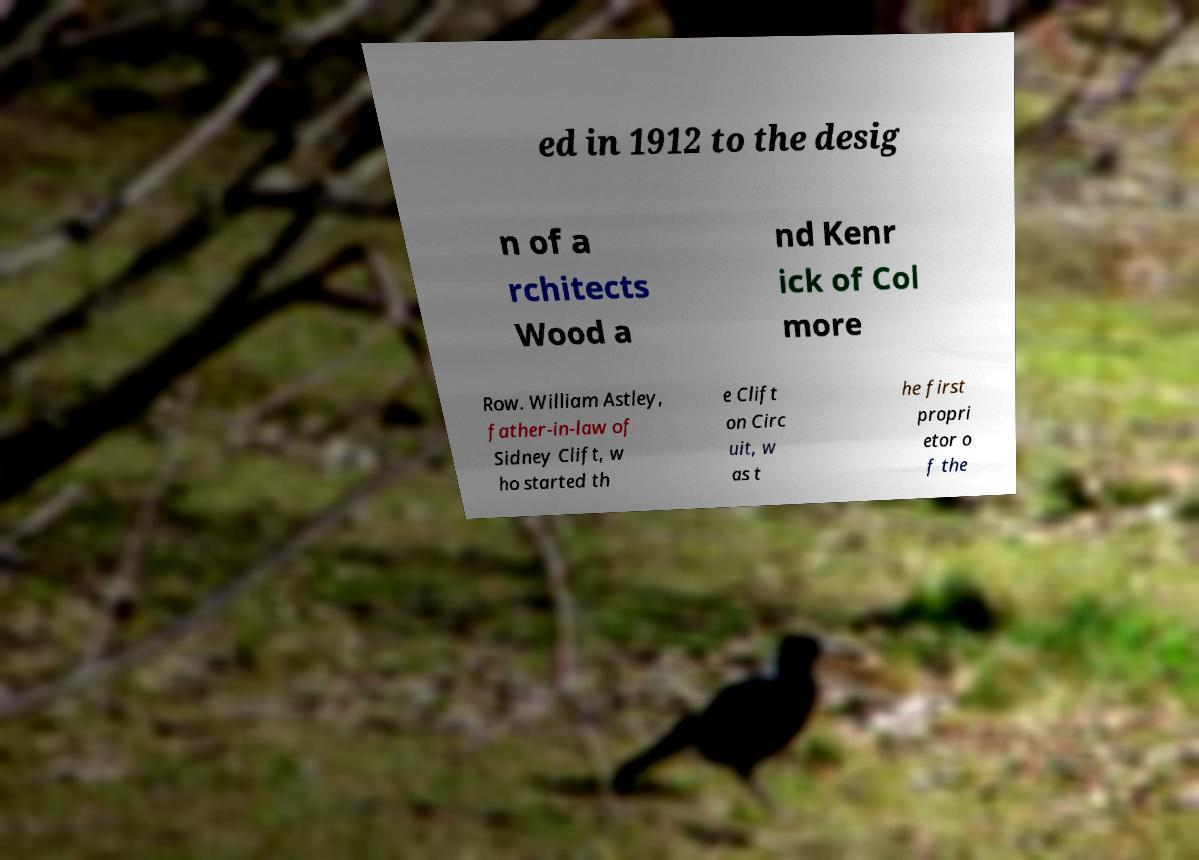Please identify and transcribe the text found in this image. ed in 1912 to the desig n of a rchitects Wood a nd Kenr ick of Col more Row. William Astley, father-in-law of Sidney Clift, w ho started th e Clift on Circ uit, w as t he first propri etor o f the 